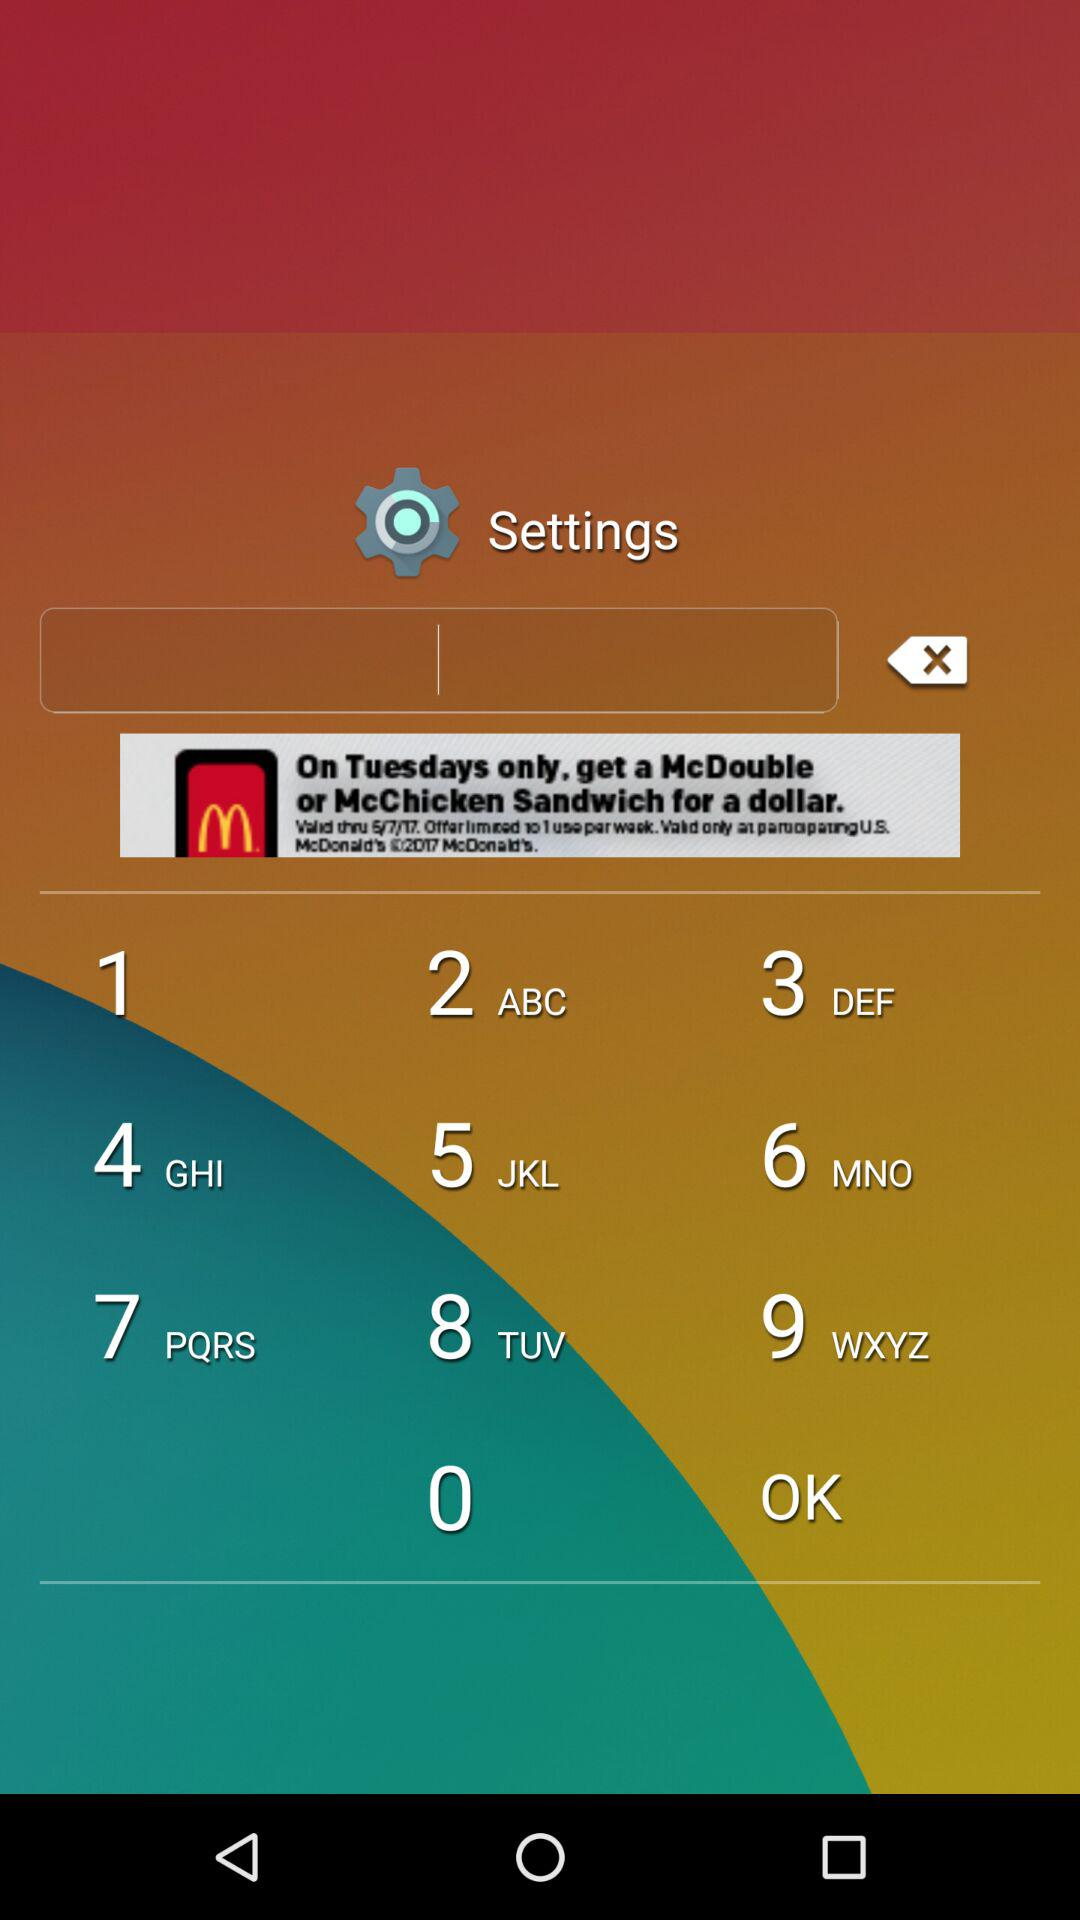How many terms of service are there?
Answer the question using a single word or phrase. 5 